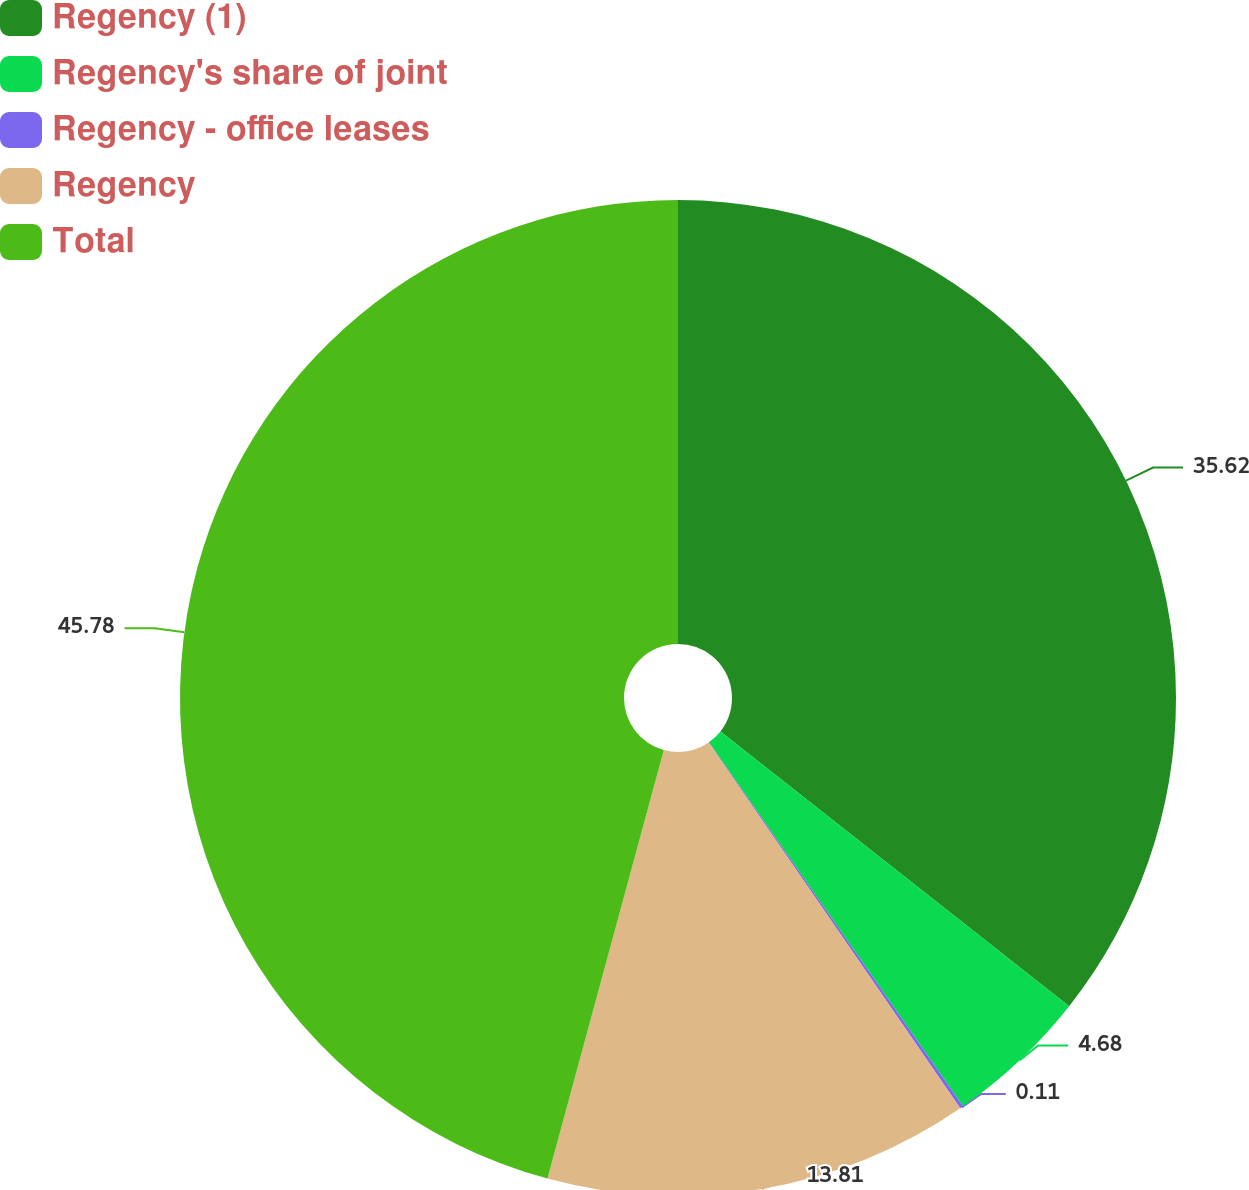Convert chart. <chart><loc_0><loc_0><loc_500><loc_500><pie_chart><fcel>Regency (1)<fcel>Regency's share of joint<fcel>Regency - office leases<fcel>Regency<fcel>Total<nl><fcel>35.62%<fcel>4.68%<fcel>0.11%<fcel>13.81%<fcel>45.78%<nl></chart> 